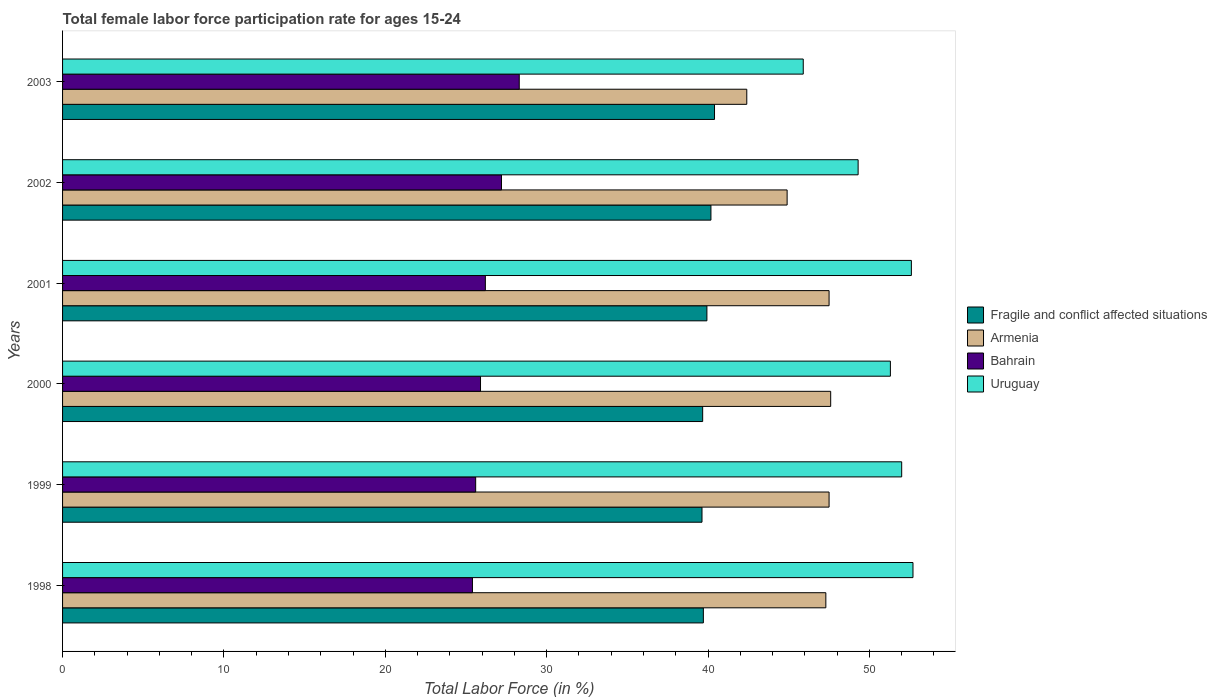How many groups of bars are there?
Your answer should be very brief. 6. Are the number of bars on each tick of the Y-axis equal?
Your answer should be compact. Yes. How many bars are there on the 5th tick from the top?
Keep it short and to the point. 4. In how many cases, is the number of bars for a given year not equal to the number of legend labels?
Your answer should be compact. 0. What is the female labor force participation rate in Armenia in 2001?
Offer a very short reply. 47.5. Across all years, what is the maximum female labor force participation rate in Armenia?
Offer a terse response. 47.6. Across all years, what is the minimum female labor force participation rate in Uruguay?
Your answer should be very brief. 45.9. What is the total female labor force participation rate in Uruguay in the graph?
Offer a terse response. 303.8. What is the difference between the female labor force participation rate in Fragile and conflict affected situations in 1998 and that in 2003?
Provide a succinct answer. -0.69. What is the difference between the female labor force participation rate in Fragile and conflict affected situations in 1998 and the female labor force participation rate in Uruguay in 2001?
Offer a terse response. -12.89. What is the average female labor force participation rate in Armenia per year?
Provide a succinct answer. 46.2. In the year 2000, what is the difference between the female labor force participation rate in Bahrain and female labor force participation rate in Armenia?
Your answer should be compact. -21.7. In how many years, is the female labor force participation rate in Fragile and conflict affected situations greater than 26 %?
Keep it short and to the point. 6. What is the ratio of the female labor force participation rate in Uruguay in 1999 to that in 2001?
Give a very brief answer. 0.99. What is the difference between the highest and the second highest female labor force participation rate in Bahrain?
Provide a short and direct response. 1.1. What is the difference between the highest and the lowest female labor force participation rate in Uruguay?
Give a very brief answer. 6.8. In how many years, is the female labor force participation rate in Uruguay greater than the average female labor force participation rate in Uruguay taken over all years?
Keep it short and to the point. 4. Is the sum of the female labor force participation rate in Fragile and conflict affected situations in 1998 and 1999 greater than the maximum female labor force participation rate in Bahrain across all years?
Make the answer very short. Yes. What does the 1st bar from the top in 2001 represents?
Make the answer very short. Uruguay. What does the 4th bar from the bottom in 2001 represents?
Keep it short and to the point. Uruguay. Is it the case that in every year, the sum of the female labor force participation rate in Uruguay and female labor force participation rate in Bahrain is greater than the female labor force participation rate in Fragile and conflict affected situations?
Ensure brevity in your answer.  Yes. How many bars are there?
Offer a very short reply. 24. Are all the bars in the graph horizontal?
Provide a short and direct response. Yes. Where does the legend appear in the graph?
Provide a short and direct response. Center right. How many legend labels are there?
Provide a succinct answer. 4. What is the title of the graph?
Offer a terse response. Total female labor force participation rate for ages 15-24. What is the label or title of the X-axis?
Keep it short and to the point. Total Labor Force (in %). What is the label or title of the Y-axis?
Your answer should be very brief. Years. What is the Total Labor Force (in %) of Fragile and conflict affected situations in 1998?
Your answer should be compact. 39.71. What is the Total Labor Force (in %) of Armenia in 1998?
Offer a very short reply. 47.3. What is the Total Labor Force (in %) in Bahrain in 1998?
Keep it short and to the point. 25.4. What is the Total Labor Force (in %) in Uruguay in 1998?
Your answer should be compact. 52.7. What is the Total Labor Force (in %) of Fragile and conflict affected situations in 1999?
Your answer should be compact. 39.63. What is the Total Labor Force (in %) in Armenia in 1999?
Keep it short and to the point. 47.5. What is the Total Labor Force (in %) in Bahrain in 1999?
Give a very brief answer. 25.6. What is the Total Labor Force (in %) of Fragile and conflict affected situations in 2000?
Your answer should be very brief. 39.67. What is the Total Labor Force (in %) in Armenia in 2000?
Keep it short and to the point. 47.6. What is the Total Labor Force (in %) of Bahrain in 2000?
Provide a succinct answer. 25.9. What is the Total Labor Force (in %) in Uruguay in 2000?
Your response must be concise. 51.3. What is the Total Labor Force (in %) of Fragile and conflict affected situations in 2001?
Give a very brief answer. 39.93. What is the Total Labor Force (in %) of Armenia in 2001?
Your response must be concise. 47.5. What is the Total Labor Force (in %) in Bahrain in 2001?
Your answer should be compact. 26.2. What is the Total Labor Force (in %) in Uruguay in 2001?
Keep it short and to the point. 52.6. What is the Total Labor Force (in %) of Fragile and conflict affected situations in 2002?
Provide a short and direct response. 40.18. What is the Total Labor Force (in %) in Armenia in 2002?
Provide a short and direct response. 44.9. What is the Total Labor Force (in %) in Bahrain in 2002?
Provide a short and direct response. 27.2. What is the Total Labor Force (in %) of Uruguay in 2002?
Offer a terse response. 49.3. What is the Total Labor Force (in %) of Fragile and conflict affected situations in 2003?
Offer a very short reply. 40.4. What is the Total Labor Force (in %) in Armenia in 2003?
Offer a very short reply. 42.4. What is the Total Labor Force (in %) in Bahrain in 2003?
Provide a succinct answer. 28.3. What is the Total Labor Force (in %) of Uruguay in 2003?
Your answer should be compact. 45.9. Across all years, what is the maximum Total Labor Force (in %) in Fragile and conflict affected situations?
Your answer should be very brief. 40.4. Across all years, what is the maximum Total Labor Force (in %) in Armenia?
Keep it short and to the point. 47.6. Across all years, what is the maximum Total Labor Force (in %) of Bahrain?
Keep it short and to the point. 28.3. Across all years, what is the maximum Total Labor Force (in %) of Uruguay?
Offer a terse response. 52.7. Across all years, what is the minimum Total Labor Force (in %) of Fragile and conflict affected situations?
Keep it short and to the point. 39.63. Across all years, what is the minimum Total Labor Force (in %) in Armenia?
Your answer should be very brief. 42.4. Across all years, what is the minimum Total Labor Force (in %) in Bahrain?
Your answer should be very brief. 25.4. Across all years, what is the minimum Total Labor Force (in %) of Uruguay?
Your answer should be compact. 45.9. What is the total Total Labor Force (in %) of Fragile and conflict affected situations in the graph?
Ensure brevity in your answer.  239.51. What is the total Total Labor Force (in %) of Armenia in the graph?
Ensure brevity in your answer.  277.2. What is the total Total Labor Force (in %) of Bahrain in the graph?
Keep it short and to the point. 158.6. What is the total Total Labor Force (in %) of Uruguay in the graph?
Make the answer very short. 303.8. What is the difference between the Total Labor Force (in %) in Fragile and conflict affected situations in 1998 and that in 1999?
Ensure brevity in your answer.  0.08. What is the difference between the Total Labor Force (in %) in Bahrain in 1998 and that in 1999?
Provide a short and direct response. -0.2. What is the difference between the Total Labor Force (in %) in Uruguay in 1998 and that in 1999?
Provide a short and direct response. 0.7. What is the difference between the Total Labor Force (in %) of Fragile and conflict affected situations in 1998 and that in 2000?
Ensure brevity in your answer.  0.04. What is the difference between the Total Labor Force (in %) of Fragile and conflict affected situations in 1998 and that in 2001?
Your response must be concise. -0.22. What is the difference between the Total Labor Force (in %) in Armenia in 1998 and that in 2001?
Your answer should be compact. -0.2. What is the difference between the Total Labor Force (in %) in Uruguay in 1998 and that in 2001?
Provide a succinct answer. 0.1. What is the difference between the Total Labor Force (in %) in Fragile and conflict affected situations in 1998 and that in 2002?
Offer a terse response. -0.47. What is the difference between the Total Labor Force (in %) of Bahrain in 1998 and that in 2002?
Your answer should be very brief. -1.8. What is the difference between the Total Labor Force (in %) in Uruguay in 1998 and that in 2002?
Provide a short and direct response. 3.4. What is the difference between the Total Labor Force (in %) in Fragile and conflict affected situations in 1998 and that in 2003?
Your answer should be very brief. -0.69. What is the difference between the Total Labor Force (in %) of Bahrain in 1998 and that in 2003?
Ensure brevity in your answer.  -2.9. What is the difference between the Total Labor Force (in %) of Uruguay in 1998 and that in 2003?
Your answer should be compact. 6.8. What is the difference between the Total Labor Force (in %) of Fragile and conflict affected situations in 1999 and that in 2000?
Offer a very short reply. -0.04. What is the difference between the Total Labor Force (in %) in Armenia in 1999 and that in 2000?
Your answer should be compact. -0.1. What is the difference between the Total Labor Force (in %) in Bahrain in 1999 and that in 2000?
Provide a short and direct response. -0.3. What is the difference between the Total Labor Force (in %) of Fragile and conflict affected situations in 1999 and that in 2001?
Your answer should be very brief. -0.3. What is the difference between the Total Labor Force (in %) in Armenia in 1999 and that in 2001?
Keep it short and to the point. 0. What is the difference between the Total Labor Force (in %) in Fragile and conflict affected situations in 1999 and that in 2002?
Your response must be concise. -0.55. What is the difference between the Total Labor Force (in %) in Armenia in 1999 and that in 2002?
Your answer should be compact. 2.6. What is the difference between the Total Labor Force (in %) of Bahrain in 1999 and that in 2002?
Your response must be concise. -1.6. What is the difference between the Total Labor Force (in %) of Fragile and conflict affected situations in 1999 and that in 2003?
Offer a very short reply. -0.78. What is the difference between the Total Labor Force (in %) of Bahrain in 1999 and that in 2003?
Make the answer very short. -2.7. What is the difference between the Total Labor Force (in %) of Uruguay in 1999 and that in 2003?
Make the answer very short. 6.1. What is the difference between the Total Labor Force (in %) in Fragile and conflict affected situations in 2000 and that in 2001?
Offer a very short reply. -0.26. What is the difference between the Total Labor Force (in %) in Bahrain in 2000 and that in 2001?
Your answer should be very brief. -0.3. What is the difference between the Total Labor Force (in %) in Fragile and conflict affected situations in 2000 and that in 2002?
Keep it short and to the point. -0.51. What is the difference between the Total Labor Force (in %) of Uruguay in 2000 and that in 2002?
Ensure brevity in your answer.  2. What is the difference between the Total Labor Force (in %) in Fragile and conflict affected situations in 2000 and that in 2003?
Provide a short and direct response. -0.73. What is the difference between the Total Labor Force (in %) in Armenia in 2000 and that in 2003?
Keep it short and to the point. 5.2. What is the difference between the Total Labor Force (in %) of Uruguay in 2000 and that in 2003?
Provide a succinct answer. 5.4. What is the difference between the Total Labor Force (in %) of Fragile and conflict affected situations in 2001 and that in 2002?
Give a very brief answer. -0.25. What is the difference between the Total Labor Force (in %) in Fragile and conflict affected situations in 2001 and that in 2003?
Your answer should be compact. -0.47. What is the difference between the Total Labor Force (in %) in Armenia in 2001 and that in 2003?
Provide a short and direct response. 5.1. What is the difference between the Total Labor Force (in %) in Fragile and conflict affected situations in 2002 and that in 2003?
Give a very brief answer. -0.22. What is the difference between the Total Labor Force (in %) in Bahrain in 2002 and that in 2003?
Offer a very short reply. -1.1. What is the difference between the Total Labor Force (in %) of Fragile and conflict affected situations in 1998 and the Total Labor Force (in %) of Armenia in 1999?
Offer a terse response. -7.79. What is the difference between the Total Labor Force (in %) in Fragile and conflict affected situations in 1998 and the Total Labor Force (in %) in Bahrain in 1999?
Provide a succinct answer. 14.11. What is the difference between the Total Labor Force (in %) in Fragile and conflict affected situations in 1998 and the Total Labor Force (in %) in Uruguay in 1999?
Give a very brief answer. -12.29. What is the difference between the Total Labor Force (in %) in Armenia in 1998 and the Total Labor Force (in %) in Bahrain in 1999?
Offer a very short reply. 21.7. What is the difference between the Total Labor Force (in %) in Armenia in 1998 and the Total Labor Force (in %) in Uruguay in 1999?
Your answer should be compact. -4.7. What is the difference between the Total Labor Force (in %) of Bahrain in 1998 and the Total Labor Force (in %) of Uruguay in 1999?
Give a very brief answer. -26.6. What is the difference between the Total Labor Force (in %) in Fragile and conflict affected situations in 1998 and the Total Labor Force (in %) in Armenia in 2000?
Provide a short and direct response. -7.89. What is the difference between the Total Labor Force (in %) of Fragile and conflict affected situations in 1998 and the Total Labor Force (in %) of Bahrain in 2000?
Ensure brevity in your answer.  13.81. What is the difference between the Total Labor Force (in %) in Fragile and conflict affected situations in 1998 and the Total Labor Force (in %) in Uruguay in 2000?
Offer a terse response. -11.59. What is the difference between the Total Labor Force (in %) of Armenia in 1998 and the Total Labor Force (in %) of Bahrain in 2000?
Provide a short and direct response. 21.4. What is the difference between the Total Labor Force (in %) of Armenia in 1998 and the Total Labor Force (in %) of Uruguay in 2000?
Give a very brief answer. -4. What is the difference between the Total Labor Force (in %) in Bahrain in 1998 and the Total Labor Force (in %) in Uruguay in 2000?
Offer a very short reply. -25.9. What is the difference between the Total Labor Force (in %) of Fragile and conflict affected situations in 1998 and the Total Labor Force (in %) of Armenia in 2001?
Ensure brevity in your answer.  -7.79. What is the difference between the Total Labor Force (in %) in Fragile and conflict affected situations in 1998 and the Total Labor Force (in %) in Bahrain in 2001?
Give a very brief answer. 13.51. What is the difference between the Total Labor Force (in %) of Fragile and conflict affected situations in 1998 and the Total Labor Force (in %) of Uruguay in 2001?
Make the answer very short. -12.89. What is the difference between the Total Labor Force (in %) in Armenia in 1998 and the Total Labor Force (in %) in Bahrain in 2001?
Give a very brief answer. 21.1. What is the difference between the Total Labor Force (in %) of Bahrain in 1998 and the Total Labor Force (in %) of Uruguay in 2001?
Give a very brief answer. -27.2. What is the difference between the Total Labor Force (in %) of Fragile and conflict affected situations in 1998 and the Total Labor Force (in %) of Armenia in 2002?
Ensure brevity in your answer.  -5.19. What is the difference between the Total Labor Force (in %) in Fragile and conflict affected situations in 1998 and the Total Labor Force (in %) in Bahrain in 2002?
Keep it short and to the point. 12.51. What is the difference between the Total Labor Force (in %) in Fragile and conflict affected situations in 1998 and the Total Labor Force (in %) in Uruguay in 2002?
Your answer should be compact. -9.59. What is the difference between the Total Labor Force (in %) of Armenia in 1998 and the Total Labor Force (in %) of Bahrain in 2002?
Make the answer very short. 20.1. What is the difference between the Total Labor Force (in %) in Armenia in 1998 and the Total Labor Force (in %) in Uruguay in 2002?
Provide a short and direct response. -2. What is the difference between the Total Labor Force (in %) in Bahrain in 1998 and the Total Labor Force (in %) in Uruguay in 2002?
Your response must be concise. -23.9. What is the difference between the Total Labor Force (in %) in Fragile and conflict affected situations in 1998 and the Total Labor Force (in %) in Armenia in 2003?
Offer a very short reply. -2.69. What is the difference between the Total Labor Force (in %) in Fragile and conflict affected situations in 1998 and the Total Labor Force (in %) in Bahrain in 2003?
Offer a terse response. 11.41. What is the difference between the Total Labor Force (in %) in Fragile and conflict affected situations in 1998 and the Total Labor Force (in %) in Uruguay in 2003?
Provide a succinct answer. -6.19. What is the difference between the Total Labor Force (in %) in Armenia in 1998 and the Total Labor Force (in %) in Uruguay in 2003?
Your response must be concise. 1.4. What is the difference between the Total Labor Force (in %) in Bahrain in 1998 and the Total Labor Force (in %) in Uruguay in 2003?
Give a very brief answer. -20.5. What is the difference between the Total Labor Force (in %) of Fragile and conflict affected situations in 1999 and the Total Labor Force (in %) of Armenia in 2000?
Give a very brief answer. -7.97. What is the difference between the Total Labor Force (in %) in Fragile and conflict affected situations in 1999 and the Total Labor Force (in %) in Bahrain in 2000?
Offer a very short reply. 13.73. What is the difference between the Total Labor Force (in %) in Fragile and conflict affected situations in 1999 and the Total Labor Force (in %) in Uruguay in 2000?
Offer a very short reply. -11.67. What is the difference between the Total Labor Force (in %) in Armenia in 1999 and the Total Labor Force (in %) in Bahrain in 2000?
Give a very brief answer. 21.6. What is the difference between the Total Labor Force (in %) of Armenia in 1999 and the Total Labor Force (in %) of Uruguay in 2000?
Your response must be concise. -3.8. What is the difference between the Total Labor Force (in %) of Bahrain in 1999 and the Total Labor Force (in %) of Uruguay in 2000?
Offer a terse response. -25.7. What is the difference between the Total Labor Force (in %) in Fragile and conflict affected situations in 1999 and the Total Labor Force (in %) in Armenia in 2001?
Keep it short and to the point. -7.87. What is the difference between the Total Labor Force (in %) in Fragile and conflict affected situations in 1999 and the Total Labor Force (in %) in Bahrain in 2001?
Your response must be concise. 13.43. What is the difference between the Total Labor Force (in %) in Fragile and conflict affected situations in 1999 and the Total Labor Force (in %) in Uruguay in 2001?
Ensure brevity in your answer.  -12.97. What is the difference between the Total Labor Force (in %) in Armenia in 1999 and the Total Labor Force (in %) in Bahrain in 2001?
Keep it short and to the point. 21.3. What is the difference between the Total Labor Force (in %) in Armenia in 1999 and the Total Labor Force (in %) in Uruguay in 2001?
Keep it short and to the point. -5.1. What is the difference between the Total Labor Force (in %) in Fragile and conflict affected situations in 1999 and the Total Labor Force (in %) in Armenia in 2002?
Your answer should be compact. -5.27. What is the difference between the Total Labor Force (in %) of Fragile and conflict affected situations in 1999 and the Total Labor Force (in %) of Bahrain in 2002?
Your answer should be compact. 12.43. What is the difference between the Total Labor Force (in %) in Fragile and conflict affected situations in 1999 and the Total Labor Force (in %) in Uruguay in 2002?
Your response must be concise. -9.67. What is the difference between the Total Labor Force (in %) in Armenia in 1999 and the Total Labor Force (in %) in Bahrain in 2002?
Offer a very short reply. 20.3. What is the difference between the Total Labor Force (in %) in Armenia in 1999 and the Total Labor Force (in %) in Uruguay in 2002?
Your response must be concise. -1.8. What is the difference between the Total Labor Force (in %) in Bahrain in 1999 and the Total Labor Force (in %) in Uruguay in 2002?
Your response must be concise. -23.7. What is the difference between the Total Labor Force (in %) of Fragile and conflict affected situations in 1999 and the Total Labor Force (in %) of Armenia in 2003?
Make the answer very short. -2.77. What is the difference between the Total Labor Force (in %) in Fragile and conflict affected situations in 1999 and the Total Labor Force (in %) in Bahrain in 2003?
Ensure brevity in your answer.  11.33. What is the difference between the Total Labor Force (in %) in Fragile and conflict affected situations in 1999 and the Total Labor Force (in %) in Uruguay in 2003?
Your answer should be very brief. -6.27. What is the difference between the Total Labor Force (in %) in Armenia in 1999 and the Total Labor Force (in %) in Bahrain in 2003?
Your response must be concise. 19.2. What is the difference between the Total Labor Force (in %) in Armenia in 1999 and the Total Labor Force (in %) in Uruguay in 2003?
Provide a short and direct response. 1.6. What is the difference between the Total Labor Force (in %) of Bahrain in 1999 and the Total Labor Force (in %) of Uruguay in 2003?
Your response must be concise. -20.3. What is the difference between the Total Labor Force (in %) of Fragile and conflict affected situations in 2000 and the Total Labor Force (in %) of Armenia in 2001?
Keep it short and to the point. -7.83. What is the difference between the Total Labor Force (in %) of Fragile and conflict affected situations in 2000 and the Total Labor Force (in %) of Bahrain in 2001?
Keep it short and to the point. 13.47. What is the difference between the Total Labor Force (in %) of Fragile and conflict affected situations in 2000 and the Total Labor Force (in %) of Uruguay in 2001?
Make the answer very short. -12.93. What is the difference between the Total Labor Force (in %) of Armenia in 2000 and the Total Labor Force (in %) of Bahrain in 2001?
Your answer should be compact. 21.4. What is the difference between the Total Labor Force (in %) in Bahrain in 2000 and the Total Labor Force (in %) in Uruguay in 2001?
Ensure brevity in your answer.  -26.7. What is the difference between the Total Labor Force (in %) in Fragile and conflict affected situations in 2000 and the Total Labor Force (in %) in Armenia in 2002?
Offer a terse response. -5.23. What is the difference between the Total Labor Force (in %) of Fragile and conflict affected situations in 2000 and the Total Labor Force (in %) of Bahrain in 2002?
Provide a succinct answer. 12.47. What is the difference between the Total Labor Force (in %) of Fragile and conflict affected situations in 2000 and the Total Labor Force (in %) of Uruguay in 2002?
Ensure brevity in your answer.  -9.63. What is the difference between the Total Labor Force (in %) in Armenia in 2000 and the Total Labor Force (in %) in Bahrain in 2002?
Keep it short and to the point. 20.4. What is the difference between the Total Labor Force (in %) in Bahrain in 2000 and the Total Labor Force (in %) in Uruguay in 2002?
Provide a short and direct response. -23.4. What is the difference between the Total Labor Force (in %) of Fragile and conflict affected situations in 2000 and the Total Labor Force (in %) of Armenia in 2003?
Give a very brief answer. -2.73. What is the difference between the Total Labor Force (in %) of Fragile and conflict affected situations in 2000 and the Total Labor Force (in %) of Bahrain in 2003?
Offer a very short reply. 11.37. What is the difference between the Total Labor Force (in %) in Fragile and conflict affected situations in 2000 and the Total Labor Force (in %) in Uruguay in 2003?
Make the answer very short. -6.23. What is the difference between the Total Labor Force (in %) of Armenia in 2000 and the Total Labor Force (in %) of Bahrain in 2003?
Your answer should be very brief. 19.3. What is the difference between the Total Labor Force (in %) of Bahrain in 2000 and the Total Labor Force (in %) of Uruguay in 2003?
Your answer should be compact. -20. What is the difference between the Total Labor Force (in %) of Fragile and conflict affected situations in 2001 and the Total Labor Force (in %) of Armenia in 2002?
Your answer should be very brief. -4.97. What is the difference between the Total Labor Force (in %) in Fragile and conflict affected situations in 2001 and the Total Labor Force (in %) in Bahrain in 2002?
Your response must be concise. 12.73. What is the difference between the Total Labor Force (in %) of Fragile and conflict affected situations in 2001 and the Total Labor Force (in %) of Uruguay in 2002?
Provide a short and direct response. -9.37. What is the difference between the Total Labor Force (in %) in Armenia in 2001 and the Total Labor Force (in %) in Bahrain in 2002?
Provide a succinct answer. 20.3. What is the difference between the Total Labor Force (in %) in Armenia in 2001 and the Total Labor Force (in %) in Uruguay in 2002?
Offer a very short reply. -1.8. What is the difference between the Total Labor Force (in %) in Bahrain in 2001 and the Total Labor Force (in %) in Uruguay in 2002?
Give a very brief answer. -23.1. What is the difference between the Total Labor Force (in %) in Fragile and conflict affected situations in 2001 and the Total Labor Force (in %) in Armenia in 2003?
Your answer should be compact. -2.47. What is the difference between the Total Labor Force (in %) in Fragile and conflict affected situations in 2001 and the Total Labor Force (in %) in Bahrain in 2003?
Your answer should be compact. 11.63. What is the difference between the Total Labor Force (in %) in Fragile and conflict affected situations in 2001 and the Total Labor Force (in %) in Uruguay in 2003?
Ensure brevity in your answer.  -5.97. What is the difference between the Total Labor Force (in %) in Armenia in 2001 and the Total Labor Force (in %) in Bahrain in 2003?
Offer a terse response. 19.2. What is the difference between the Total Labor Force (in %) of Bahrain in 2001 and the Total Labor Force (in %) of Uruguay in 2003?
Ensure brevity in your answer.  -19.7. What is the difference between the Total Labor Force (in %) of Fragile and conflict affected situations in 2002 and the Total Labor Force (in %) of Armenia in 2003?
Offer a very short reply. -2.22. What is the difference between the Total Labor Force (in %) in Fragile and conflict affected situations in 2002 and the Total Labor Force (in %) in Bahrain in 2003?
Offer a terse response. 11.88. What is the difference between the Total Labor Force (in %) in Fragile and conflict affected situations in 2002 and the Total Labor Force (in %) in Uruguay in 2003?
Offer a terse response. -5.72. What is the difference between the Total Labor Force (in %) in Armenia in 2002 and the Total Labor Force (in %) in Uruguay in 2003?
Offer a terse response. -1. What is the difference between the Total Labor Force (in %) in Bahrain in 2002 and the Total Labor Force (in %) in Uruguay in 2003?
Provide a short and direct response. -18.7. What is the average Total Labor Force (in %) in Fragile and conflict affected situations per year?
Make the answer very short. 39.92. What is the average Total Labor Force (in %) of Armenia per year?
Keep it short and to the point. 46.2. What is the average Total Labor Force (in %) of Bahrain per year?
Ensure brevity in your answer.  26.43. What is the average Total Labor Force (in %) in Uruguay per year?
Offer a terse response. 50.63. In the year 1998, what is the difference between the Total Labor Force (in %) of Fragile and conflict affected situations and Total Labor Force (in %) of Armenia?
Your answer should be compact. -7.59. In the year 1998, what is the difference between the Total Labor Force (in %) in Fragile and conflict affected situations and Total Labor Force (in %) in Bahrain?
Your answer should be compact. 14.31. In the year 1998, what is the difference between the Total Labor Force (in %) of Fragile and conflict affected situations and Total Labor Force (in %) of Uruguay?
Offer a terse response. -12.99. In the year 1998, what is the difference between the Total Labor Force (in %) in Armenia and Total Labor Force (in %) in Bahrain?
Your answer should be compact. 21.9. In the year 1998, what is the difference between the Total Labor Force (in %) of Armenia and Total Labor Force (in %) of Uruguay?
Offer a very short reply. -5.4. In the year 1998, what is the difference between the Total Labor Force (in %) in Bahrain and Total Labor Force (in %) in Uruguay?
Your answer should be very brief. -27.3. In the year 1999, what is the difference between the Total Labor Force (in %) of Fragile and conflict affected situations and Total Labor Force (in %) of Armenia?
Your answer should be compact. -7.87. In the year 1999, what is the difference between the Total Labor Force (in %) of Fragile and conflict affected situations and Total Labor Force (in %) of Bahrain?
Ensure brevity in your answer.  14.03. In the year 1999, what is the difference between the Total Labor Force (in %) of Fragile and conflict affected situations and Total Labor Force (in %) of Uruguay?
Provide a succinct answer. -12.37. In the year 1999, what is the difference between the Total Labor Force (in %) in Armenia and Total Labor Force (in %) in Bahrain?
Your response must be concise. 21.9. In the year 1999, what is the difference between the Total Labor Force (in %) of Bahrain and Total Labor Force (in %) of Uruguay?
Your response must be concise. -26.4. In the year 2000, what is the difference between the Total Labor Force (in %) of Fragile and conflict affected situations and Total Labor Force (in %) of Armenia?
Provide a short and direct response. -7.93. In the year 2000, what is the difference between the Total Labor Force (in %) of Fragile and conflict affected situations and Total Labor Force (in %) of Bahrain?
Ensure brevity in your answer.  13.77. In the year 2000, what is the difference between the Total Labor Force (in %) of Fragile and conflict affected situations and Total Labor Force (in %) of Uruguay?
Your answer should be very brief. -11.63. In the year 2000, what is the difference between the Total Labor Force (in %) in Armenia and Total Labor Force (in %) in Bahrain?
Ensure brevity in your answer.  21.7. In the year 2000, what is the difference between the Total Labor Force (in %) in Armenia and Total Labor Force (in %) in Uruguay?
Ensure brevity in your answer.  -3.7. In the year 2000, what is the difference between the Total Labor Force (in %) of Bahrain and Total Labor Force (in %) of Uruguay?
Your answer should be very brief. -25.4. In the year 2001, what is the difference between the Total Labor Force (in %) in Fragile and conflict affected situations and Total Labor Force (in %) in Armenia?
Your response must be concise. -7.57. In the year 2001, what is the difference between the Total Labor Force (in %) in Fragile and conflict affected situations and Total Labor Force (in %) in Bahrain?
Provide a short and direct response. 13.73. In the year 2001, what is the difference between the Total Labor Force (in %) of Fragile and conflict affected situations and Total Labor Force (in %) of Uruguay?
Provide a short and direct response. -12.67. In the year 2001, what is the difference between the Total Labor Force (in %) in Armenia and Total Labor Force (in %) in Bahrain?
Offer a terse response. 21.3. In the year 2001, what is the difference between the Total Labor Force (in %) in Bahrain and Total Labor Force (in %) in Uruguay?
Provide a succinct answer. -26.4. In the year 2002, what is the difference between the Total Labor Force (in %) of Fragile and conflict affected situations and Total Labor Force (in %) of Armenia?
Your answer should be compact. -4.72. In the year 2002, what is the difference between the Total Labor Force (in %) in Fragile and conflict affected situations and Total Labor Force (in %) in Bahrain?
Offer a very short reply. 12.98. In the year 2002, what is the difference between the Total Labor Force (in %) of Fragile and conflict affected situations and Total Labor Force (in %) of Uruguay?
Offer a terse response. -9.12. In the year 2002, what is the difference between the Total Labor Force (in %) in Armenia and Total Labor Force (in %) in Bahrain?
Your answer should be compact. 17.7. In the year 2002, what is the difference between the Total Labor Force (in %) of Armenia and Total Labor Force (in %) of Uruguay?
Your answer should be very brief. -4.4. In the year 2002, what is the difference between the Total Labor Force (in %) of Bahrain and Total Labor Force (in %) of Uruguay?
Make the answer very short. -22.1. In the year 2003, what is the difference between the Total Labor Force (in %) in Fragile and conflict affected situations and Total Labor Force (in %) in Armenia?
Offer a very short reply. -2. In the year 2003, what is the difference between the Total Labor Force (in %) in Fragile and conflict affected situations and Total Labor Force (in %) in Bahrain?
Keep it short and to the point. 12.1. In the year 2003, what is the difference between the Total Labor Force (in %) in Fragile and conflict affected situations and Total Labor Force (in %) in Uruguay?
Your answer should be compact. -5.5. In the year 2003, what is the difference between the Total Labor Force (in %) in Armenia and Total Labor Force (in %) in Bahrain?
Offer a terse response. 14.1. In the year 2003, what is the difference between the Total Labor Force (in %) in Armenia and Total Labor Force (in %) in Uruguay?
Make the answer very short. -3.5. In the year 2003, what is the difference between the Total Labor Force (in %) of Bahrain and Total Labor Force (in %) of Uruguay?
Make the answer very short. -17.6. What is the ratio of the Total Labor Force (in %) in Fragile and conflict affected situations in 1998 to that in 1999?
Your answer should be very brief. 1. What is the ratio of the Total Labor Force (in %) in Bahrain in 1998 to that in 1999?
Your response must be concise. 0.99. What is the ratio of the Total Labor Force (in %) in Uruguay in 1998 to that in 1999?
Provide a succinct answer. 1.01. What is the ratio of the Total Labor Force (in %) in Bahrain in 1998 to that in 2000?
Keep it short and to the point. 0.98. What is the ratio of the Total Labor Force (in %) of Uruguay in 1998 to that in 2000?
Offer a terse response. 1.03. What is the ratio of the Total Labor Force (in %) in Bahrain in 1998 to that in 2001?
Offer a very short reply. 0.97. What is the ratio of the Total Labor Force (in %) in Fragile and conflict affected situations in 1998 to that in 2002?
Your answer should be compact. 0.99. What is the ratio of the Total Labor Force (in %) in Armenia in 1998 to that in 2002?
Keep it short and to the point. 1.05. What is the ratio of the Total Labor Force (in %) in Bahrain in 1998 to that in 2002?
Offer a very short reply. 0.93. What is the ratio of the Total Labor Force (in %) in Uruguay in 1998 to that in 2002?
Keep it short and to the point. 1.07. What is the ratio of the Total Labor Force (in %) in Fragile and conflict affected situations in 1998 to that in 2003?
Give a very brief answer. 0.98. What is the ratio of the Total Labor Force (in %) of Armenia in 1998 to that in 2003?
Your answer should be very brief. 1.12. What is the ratio of the Total Labor Force (in %) in Bahrain in 1998 to that in 2003?
Your response must be concise. 0.9. What is the ratio of the Total Labor Force (in %) in Uruguay in 1998 to that in 2003?
Your answer should be very brief. 1.15. What is the ratio of the Total Labor Force (in %) of Fragile and conflict affected situations in 1999 to that in 2000?
Your answer should be compact. 1. What is the ratio of the Total Labor Force (in %) in Bahrain in 1999 to that in 2000?
Your answer should be compact. 0.99. What is the ratio of the Total Labor Force (in %) in Uruguay in 1999 to that in 2000?
Offer a terse response. 1.01. What is the ratio of the Total Labor Force (in %) in Bahrain in 1999 to that in 2001?
Ensure brevity in your answer.  0.98. What is the ratio of the Total Labor Force (in %) of Uruguay in 1999 to that in 2001?
Give a very brief answer. 0.99. What is the ratio of the Total Labor Force (in %) of Fragile and conflict affected situations in 1999 to that in 2002?
Your answer should be compact. 0.99. What is the ratio of the Total Labor Force (in %) of Armenia in 1999 to that in 2002?
Keep it short and to the point. 1.06. What is the ratio of the Total Labor Force (in %) of Uruguay in 1999 to that in 2002?
Ensure brevity in your answer.  1.05. What is the ratio of the Total Labor Force (in %) in Fragile and conflict affected situations in 1999 to that in 2003?
Provide a succinct answer. 0.98. What is the ratio of the Total Labor Force (in %) in Armenia in 1999 to that in 2003?
Offer a terse response. 1.12. What is the ratio of the Total Labor Force (in %) in Bahrain in 1999 to that in 2003?
Give a very brief answer. 0.9. What is the ratio of the Total Labor Force (in %) in Uruguay in 1999 to that in 2003?
Provide a short and direct response. 1.13. What is the ratio of the Total Labor Force (in %) of Armenia in 2000 to that in 2001?
Give a very brief answer. 1. What is the ratio of the Total Labor Force (in %) in Bahrain in 2000 to that in 2001?
Provide a succinct answer. 0.99. What is the ratio of the Total Labor Force (in %) of Uruguay in 2000 to that in 2001?
Give a very brief answer. 0.98. What is the ratio of the Total Labor Force (in %) in Fragile and conflict affected situations in 2000 to that in 2002?
Make the answer very short. 0.99. What is the ratio of the Total Labor Force (in %) of Armenia in 2000 to that in 2002?
Offer a very short reply. 1.06. What is the ratio of the Total Labor Force (in %) of Bahrain in 2000 to that in 2002?
Keep it short and to the point. 0.95. What is the ratio of the Total Labor Force (in %) of Uruguay in 2000 to that in 2002?
Give a very brief answer. 1.04. What is the ratio of the Total Labor Force (in %) in Fragile and conflict affected situations in 2000 to that in 2003?
Provide a succinct answer. 0.98. What is the ratio of the Total Labor Force (in %) of Armenia in 2000 to that in 2003?
Make the answer very short. 1.12. What is the ratio of the Total Labor Force (in %) in Bahrain in 2000 to that in 2003?
Your response must be concise. 0.92. What is the ratio of the Total Labor Force (in %) of Uruguay in 2000 to that in 2003?
Your answer should be very brief. 1.12. What is the ratio of the Total Labor Force (in %) in Armenia in 2001 to that in 2002?
Your answer should be very brief. 1.06. What is the ratio of the Total Labor Force (in %) in Bahrain in 2001 to that in 2002?
Your answer should be compact. 0.96. What is the ratio of the Total Labor Force (in %) of Uruguay in 2001 to that in 2002?
Provide a succinct answer. 1.07. What is the ratio of the Total Labor Force (in %) of Fragile and conflict affected situations in 2001 to that in 2003?
Make the answer very short. 0.99. What is the ratio of the Total Labor Force (in %) in Armenia in 2001 to that in 2003?
Offer a very short reply. 1.12. What is the ratio of the Total Labor Force (in %) in Bahrain in 2001 to that in 2003?
Provide a short and direct response. 0.93. What is the ratio of the Total Labor Force (in %) in Uruguay in 2001 to that in 2003?
Ensure brevity in your answer.  1.15. What is the ratio of the Total Labor Force (in %) of Armenia in 2002 to that in 2003?
Provide a short and direct response. 1.06. What is the ratio of the Total Labor Force (in %) in Bahrain in 2002 to that in 2003?
Keep it short and to the point. 0.96. What is the ratio of the Total Labor Force (in %) in Uruguay in 2002 to that in 2003?
Make the answer very short. 1.07. What is the difference between the highest and the second highest Total Labor Force (in %) of Fragile and conflict affected situations?
Provide a succinct answer. 0.22. What is the difference between the highest and the second highest Total Labor Force (in %) of Armenia?
Make the answer very short. 0.1. What is the difference between the highest and the second highest Total Labor Force (in %) in Uruguay?
Make the answer very short. 0.1. What is the difference between the highest and the lowest Total Labor Force (in %) in Fragile and conflict affected situations?
Your answer should be compact. 0.78. What is the difference between the highest and the lowest Total Labor Force (in %) of Bahrain?
Offer a terse response. 2.9. What is the difference between the highest and the lowest Total Labor Force (in %) of Uruguay?
Offer a very short reply. 6.8. 